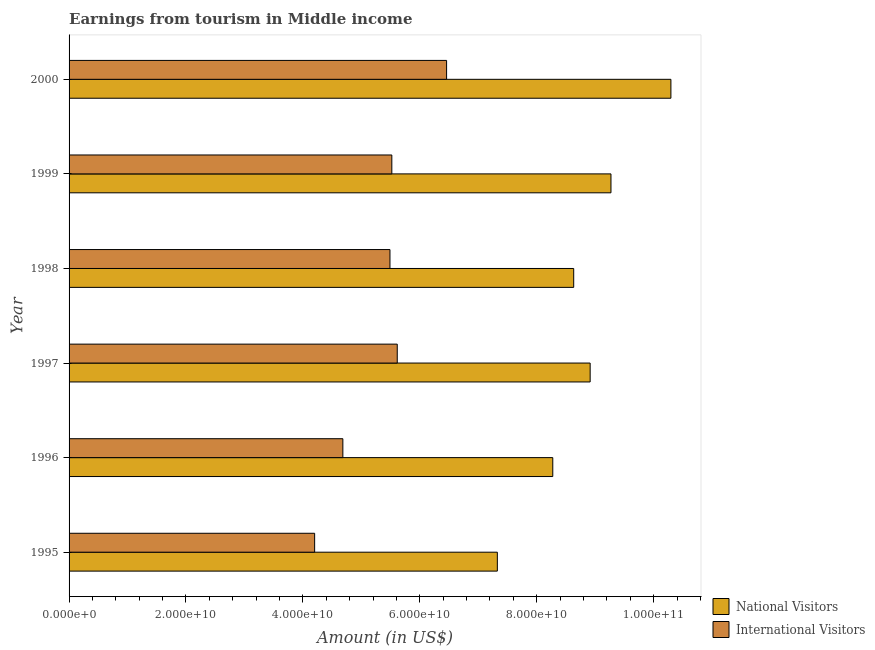How many different coloured bars are there?
Ensure brevity in your answer.  2. Are the number of bars on each tick of the Y-axis equal?
Keep it short and to the point. Yes. How many bars are there on the 6th tick from the bottom?
Your response must be concise. 2. What is the label of the 4th group of bars from the top?
Keep it short and to the point. 1997. In how many cases, is the number of bars for a given year not equal to the number of legend labels?
Ensure brevity in your answer.  0. What is the amount earned from international visitors in 1997?
Give a very brief answer. 5.61e+1. Across all years, what is the maximum amount earned from international visitors?
Offer a very short reply. 6.46e+1. Across all years, what is the minimum amount earned from national visitors?
Provide a short and direct response. 7.33e+1. In which year was the amount earned from national visitors minimum?
Ensure brevity in your answer.  1995. What is the total amount earned from national visitors in the graph?
Keep it short and to the point. 5.27e+11. What is the difference between the amount earned from national visitors in 1996 and that in 1997?
Make the answer very short. -6.39e+09. What is the difference between the amount earned from national visitors in 2000 and the amount earned from international visitors in 1998?
Give a very brief answer. 4.81e+1. What is the average amount earned from national visitors per year?
Your answer should be compact. 8.79e+1. In the year 2000, what is the difference between the amount earned from international visitors and amount earned from national visitors?
Ensure brevity in your answer.  -3.84e+1. What is the ratio of the amount earned from international visitors in 1999 to that in 2000?
Make the answer very short. 0.85. Is the difference between the amount earned from national visitors in 1998 and 1999 greater than the difference between the amount earned from international visitors in 1998 and 1999?
Your response must be concise. No. What is the difference between the highest and the second highest amount earned from international visitors?
Your answer should be compact. 8.44e+09. What is the difference between the highest and the lowest amount earned from international visitors?
Your answer should be compact. 2.26e+1. In how many years, is the amount earned from national visitors greater than the average amount earned from national visitors taken over all years?
Keep it short and to the point. 3. Is the sum of the amount earned from international visitors in 1995 and 1999 greater than the maximum amount earned from national visitors across all years?
Keep it short and to the point. No. What does the 1st bar from the top in 1998 represents?
Keep it short and to the point. International Visitors. What does the 1st bar from the bottom in 2000 represents?
Offer a terse response. National Visitors. How many bars are there?
Your answer should be compact. 12. How many years are there in the graph?
Give a very brief answer. 6. What is the difference between two consecutive major ticks on the X-axis?
Provide a succinct answer. 2.00e+1. Does the graph contain any zero values?
Offer a very short reply. No. Where does the legend appear in the graph?
Offer a terse response. Bottom right. How many legend labels are there?
Offer a terse response. 2. How are the legend labels stacked?
Your answer should be very brief. Vertical. What is the title of the graph?
Provide a succinct answer. Earnings from tourism in Middle income. Does "Canada" appear as one of the legend labels in the graph?
Your answer should be very brief. No. What is the label or title of the X-axis?
Your answer should be compact. Amount (in US$). What is the Amount (in US$) in National Visitors in 1995?
Your response must be concise. 7.33e+1. What is the Amount (in US$) of International Visitors in 1995?
Keep it short and to the point. 4.20e+1. What is the Amount (in US$) of National Visitors in 1996?
Your answer should be very brief. 8.27e+1. What is the Amount (in US$) in International Visitors in 1996?
Offer a terse response. 4.68e+1. What is the Amount (in US$) in National Visitors in 1997?
Your answer should be very brief. 8.91e+1. What is the Amount (in US$) in International Visitors in 1997?
Keep it short and to the point. 5.61e+1. What is the Amount (in US$) of National Visitors in 1998?
Offer a terse response. 8.63e+1. What is the Amount (in US$) of International Visitors in 1998?
Make the answer very short. 5.49e+1. What is the Amount (in US$) of National Visitors in 1999?
Offer a very short reply. 9.27e+1. What is the Amount (in US$) in International Visitors in 1999?
Keep it short and to the point. 5.52e+1. What is the Amount (in US$) in National Visitors in 2000?
Your response must be concise. 1.03e+11. What is the Amount (in US$) of International Visitors in 2000?
Offer a terse response. 6.46e+1. Across all years, what is the maximum Amount (in US$) in National Visitors?
Provide a succinct answer. 1.03e+11. Across all years, what is the maximum Amount (in US$) of International Visitors?
Your answer should be compact. 6.46e+1. Across all years, what is the minimum Amount (in US$) of National Visitors?
Your answer should be very brief. 7.33e+1. Across all years, what is the minimum Amount (in US$) of International Visitors?
Your answer should be compact. 4.20e+1. What is the total Amount (in US$) in National Visitors in the graph?
Make the answer very short. 5.27e+11. What is the total Amount (in US$) of International Visitors in the graph?
Your answer should be compact. 3.20e+11. What is the difference between the Amount (in US$) of National Visitors in 1995 and that in 1996?
Provide a succinct answer. -9.48e+09. What is the difference between the Amount (in US$) in International Visitors in 1995 and that in 1996?
Offer a terse response. -4.83e+09. What is the difference between the Amount (in US$) in National Visitors in 1995 and that in 1997?
Your answer should be compact. -1.59e+1. What is the difference between the Amount (in US$) of International Visitors in 1995 and that in 1997?
Keep it short and to the point. -1.41e+1. What is the difference between the Amount (in US$) of National Visitors in 1995 and that in 1998?
Offer a very short reply. -1.31e+1. What is the difference between the Amount (in US$) in International Visitors in 1995 and that in 1998?
Ensure brevity in your answer.  -1.29e+1. What is the difference between the Amount (in US$) in National Visitors in 1995 and that in 1999?
Make the answer very short. -1.94e+1. What is the difference between the Amount (in US$) in International Visitors in 1995 and that in 1999?
Ensure brevity in your answer.  -1.32e+1. What is the difference between the Amount (in US$) of National Visitors in 1995 and that in 2000?
Keep it short and to the point. -2.97e+1. What is the difference between the Amount (in US$) of International Visitors in 1995 and that in 2000?
Your answer should be compact. -2.26e+1. What is the difference between the Amount (in US$) of National Visitors in 1996 and that in 1997?
Your answer should be compact. -6.39e+09. What is the difference between the Amount (in US$) of International Visitors in 1996 and that in 1997?
Your answer should be compact. -9.30e+09. What is the difference between the Amount (in US$) in National Visitors in 1996 and that in 1998?
Offer a terse response. -3.58e+09. What is the difference between the Amount (in US$) of International Visitors in 1996 and that in 1998?
Keep it short and to the point. -8.06e+09. What is the difference between the Amount (in US$) of National Visitors in 1996 and that in 1999?
Make the answer very short. -9.95e+09. What is the difference between the Amount (in US$) in International Visitors in 1996 and that in 1999?
Give a very brief answer. -8.37e+09. What is the difference between the Amount (in US$) in National Visitors in 1996 and that in 2000?
Make the answer very short. -2.02e+1. What is the difference between the Amount (in US$) of International Visitors in 1996 and that in 2000?
Provide a short and direct response. -1.77e+1. What is the difference between the Amount (in US$) in National Visitors in 1997 and that in 1998?
Your answer should be very brief. 2.81e+09. What is the difference between the Amount (in US$) of International Visitors in 1997 and that in 1998?
Your response must be concise. 1.25e+09. What is the difference between the Amount (in US$) in National Visitors in 1997 and that in 1999?
Your answer should be compact. -3.56e+09. What is the difference between the Amount (in US$) in International Visitors in 1997 and that in 1999?
Your answer should be compact. 9.29e+08. What is the difference between the Amount (in US$) of National Visitors in 1997 and that in 2000?
Provide a short and direct response. -1.38e+1. What is the difference between the Amount (in US$) in International Visitors in 1997 and that in 2000?
Provide a succinct answer. -8.44e+09. What is the difference between the Amount (in US$) of National Visitors in 1998 and that in 1999?
Give a very brief answer. -6.37e+09. What is the difference between the Amount (in US$) in International Visitors in 1998 and that in 1999?
Ensure brevity in your answer.  -3.18e+08. What is the difference between the Amount (in US$) in National Visitors in 1998 and that in 2000?
Offer a terse response. -1.66e+1. What is the difference between the Amount (in US$) in International Visitors in 1998 and that in 2000?
Provide a succinct answer. -9.69e+09. What is the difference between the Amount (in US$) of National Visitors in 1999 and that in 2000?
Ensure brevity in your answer.  -1.03e+1. What is the difference between the Amount (in US$) of International Visitors in 1999 and that in 2000?
Offer a very short reply. -9.37e+09. What is the difference between the Amount (in US$) of National Visitors in 1995 and the Amount (in US$) of International Visitors in 1996?
Make the answer very short. 2.64e+1. What is the difference between the Amount (in US$) of National Visitors in 1995 and the Amount (in US$) of International Visitors in 1997?
Provide a succinct answer. 1.71e+1. What is the difference between the Amount (in US$) of National Visitors in 1995 and the Amount (in US$) of International Visitors in 1998?
Your response must be concise. 1.84e+1. What is the difference between the Amount (in US$) of National Visitors in 1995 and the Amount (in US$) of International Visitors in 1999?
Provide a short and direct response. 1.81e+1. What is the difference between the Amount (in US$) in National Visitors in 1995 and the Amount (in US$) in International Visitors in 2000?
Offer a very short reply. 8.68e+09. What is the difference between the Amount (in US$) in National Visitors in 1996 and the Amount (in US$) in International Visitors in 1997?
Offer a terse response. 2.66e+1. What is the difference between the Amount (in US$) of National Visitors in 1996 and the Amount (in US$) of International Visitors in 1998?
Keep it short and to the point. 2.79e+1. What is the difference between the Amount (in US$) in National Visitors in 1996 and the Amount (in US$) in International Visitors in 1999?
Your answer should be very brief. 2.75e+1. What is the difference between the Amount (in US$) in National Visitors in 1996 and the Amount (in US$) in International Visitors in 2000?
Your response must be concise. 1.82e+1. What is the difference between the Amount (in US$) in National Visitors in 1997 and the Amount (in US$) in International Visitors in 1998?
Your answer should be compact. 3.42e+1. What is the difference between the Amount (in US$) in National Visitors in 1997 and the Amount (in US$) in International Visitors in 1999?
Ensure brevity in your answer.  3.39e+1. What is the difference between the Amount (in US$) of National Visitors in 1997 and the Amount (in US$) of International Visitors in 2000?
Provide a succinct answer. 2.46e+1. What is the difference between the Amount (in US$) in National Visitors in 1998 and the Amount (in US$) in International Visitors in 1999?
Your answer should be very brief. 3.11e+1. What is the difference between the Amount (in US$) of National Visitors in 1998 and the Amount (in US$) of International Visitors in 2000?
Keep it short and to the point. 2.17e+1. What is the difference between the Amount (in US$) of National Visitors in 1999 and the Amount (in US$) of International Visitors in 2000?
Offer a terse response. 2.81e+1. What is the average Amount (in US$) in National Visitors per year?
Offer a very short reply. 8.79e+1. What is the average Amount (in US$) in International Visitors per year?
Provide a short and direct response. 5.33e+1. In the year 1995, what is the difference between the Amount (in US$) in National Visitors and Amount (in US$) in International Visitors?
Ensure brevity in your answer.  3.13e+1. In the year 1996, what is the difference between the Amount (in US$) of National Visitors and Amount (in US$) of International Visitors?
Provide a succinct answer. 3.59e+1. In the year 1997, what is the difference between the Amount (in US$) of National Visitors and Amount (in US$) of International Visitors?
Provide a succinct answer. 3.30e+1. In the year 1998, what is the difference between the Amount (in US$) in National Visitors and Amount (in US$) in International Visitors?
Keep it short and to the point. 3.14e+1. In the year 1999, what is the difference between the Amount (in US$) in National Visitors and Amount (in US$) in International Visitors?
Keep it short and to the point. 3.75e+1. In the year 2000, what is the difference between the Amount (in US$) of National Visitors and Amount (in US$) of International Visitors?
Your answer should be very brief. 3.84e+1. What is the ratio of the Amount (in US$) in National Visitors in 1995 to that in 1996?
Make the answer very short. 0.89. What is the ratio of the Amount (in US$) in International Visitors in 1995 to that in 1996?
Provide a short and direct response. 0.9. What is the ratio of the Amount (in US$) in National Visitors in 1995 to that in 1997?
Your response must be concise. 0.82. What is the ratio of the Amount (in US$) of International Visitors in 1995 to that in 1997?
Ensure brevity in your answer.  0.75. What is the ratio of the Amount (in US$) of National Visitors in 1995 to that in 1998?
Provide a short and direct response. 0.85. What is the ratio of the Amount (in US$) in International Visitors in 1995 to that in 1998?
Provide a short and direct response. 0.77. What is the ratio of the Amount (in US$) in National Visitors in 1995 to that in 1999?
Offer a terse response. 0.79. What is the ratio of the Amount (in US$) in International Visitors in 1995 to that in 1999?
Offer a very short reply. 0.76. What is the ratio of the Amount (in US$) of National Visitors in 1995 to that in 2000?
Give a very brief answer. 0.71. What is the ratio of the Amount (in US$) of International Visitors in 1995 to that in 2000?
Make the answer very short. 0.65. What is the ratio of the Amount (in US$) of National Visitors in 1996 to that in 1997?
Provide a short and direct response. 0.93. What is the ratio of the Amount (in US$) of International Visitors in 1996 to that in 1997?
Ensure brevity in your answer.  0.83. What is the ratio of the Amount (in US$) of National Visitors in 1996 to that in 1998?
Make the answer very short. 0.96. What is the ratio of the Amount (in US$) in International Visitors in 1996 to that in 1998?
Make the answer very short. 0.85. What is the ratio of the Amount (in US$) in National Visitors in 1996 to that in 1999?
Give a very brief answer. 0.89. What is the ratio of the Amount (in US$) in International Visitors in 1996 to that in 1999?
Your answer should be compact. 0.85. What is the ratio of the Amount (in US$) of National Visitors in 1996 to that in 2000?
Your answer should be very brief. 0.8. What is the ratio of the Amount (in US$) in International Visitors in 1996 to that in 2000?
Provide a short and direct response. 0.73. What is the ratio of the Amount (in US$) in National Visitors in 1997 to that in 1998?
Offer a very short reply. 1.03. What is the ratio of the Amount (in US$) in International Visitors in 1997 to that in 1998?
Your response must be concise. 1.02. What is the ratio of the Amount (in US$) of National Visitors in 1997 to that in 1999?
Ensure brevity in your answer.  0.96. What is the ratio of the Amount (in US$) of International Visitors in 1997 to that in 1999?
Ensure brevity in your answer.  1.02. What is the ratio of the Amount (in US$) of National Visitors in 1997 to that in 2000?
Your answer should be very brief. 0.87. What is the ratio of the Amount (in US$) in International Visitors in 1997 to that in 2000?
Give a very brief answer. 0.87. What is the ratio of the Amount (in US$) in National Visitors in 1998 to that in 1999?
Provide a short and direct response. 0.93. What is the ratio of the Amount (in US$) of International Visitors in 1998 to that in 1999?
Keep it short and to the point. 0.99. What is the ratio of the Amount (in US$) in National Visitors in 1998 to that in 2000?
Your answer should be compact. 0.84. What is the ratio of the Amount (in US$) of International Visitors in 1998 to that in 2000?
Offer a very short reply. 0.85. What is the ratio of the Amount (in US$) of National Visitors in 1999 to that in 2000?
Provide a succinct answer. 0.9. What is the ratio of the Amount (in US$) of International Visitors in 1999 to that in 2000?
Ensure brevity in your answer.  0.85. What is the difference between the highest and the second highest Amount (in US$) in National Visitors?
Make the answer very short. 1.03e+1. What is the difference between the highest and the second highest Amount (in US$) of International Visitors?
Provide a short and direct response. 8.44e+09. What is the difference between the highest and the lowest Amount (in US$) in National Visitors?
Your response must be concise. 2.97e+1. What is the difference between the highest and the lowest Amount (in US$) of International Visitors?
Provide a short and direct response. 2.26e+1. 